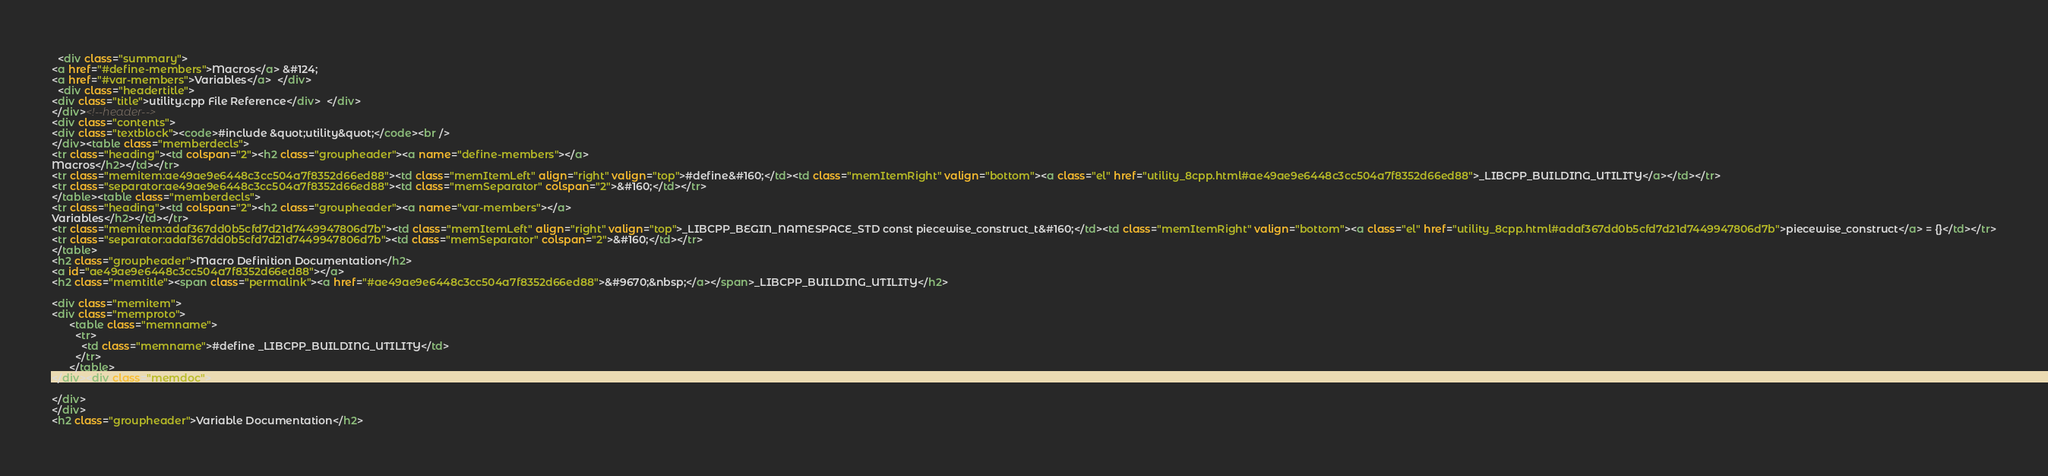<code> <loc_0><loc_0><loc_500><loc_500><_HTML_>  <div class="summary">
<a href="#define-members">Macros</a> &#124;
<a href="#var-members">Variables</a>  </div>
  <div class="headertitle">
<div class="title">utility.cpp File Reference</div>  </div>
</div><!--header-->
<div class="contents">
<div class="textblock"><code>#include &quot;utility&quot;</code><br />
</div><table class="memberdecls">
<tr class="heading"><td colspan="2"><h2 class="groupheader"><a name="define-members"></a>
Macros</h2></td></tr>
<tr class="memitem:ae49ae9e6448c3cc504a7f8352d66ed88"><td class="memItemLeft" align="right" valign="top">#define&#160;</td><td class="memItemRight" valign="bottom"><a class="el" href="utility_8cpp.html#ae49ae9e6448c3cc504a7f8352d66ed88">_LIBCPP_BUILDING_UTILITY</a></td></tr>
<tr class="separator:ae49ae9e6448c3cc504a7f8352d66ed88"><td class="memSeparator" colspan="2">&#160;</td></tr>
</table><table class="memberdecls">
<tr class="heading"><td colspan="2"><h2 class="groupheader"><a name="var-members"></a>
Variables</h2></td></tr>
<tr class="memitem:adaf367dd0b5cfd7d21d7449947806d7b"><td class="memItemLeft" align="right" valign="top">_LIBCPP_BEGIN_NAMESPACE_STD const piecewise_construct_t&#160;</td><td class="memItemRight" valign="bottom"><a class="el" href="utility_8cpp.html#adaf367dd0b5cfd7d21d7449947806d7b">piecewise_construct</a> = {}</td></tr>
<tr class="separator:adaf367dd0b5cfd7d21d7449947806d7b"><td class="memSeparator" colspan="2">&#160;</td></tr>
</table>
<h2 class="groupheader">Macro Definition Documentation</h2>
<a id="ae49ae9e6448c3cc504a7f8352d66ed88"></a>
<h2 class="memtitle"><span class="permalink"><a href="#ae49ae9e6448c3cc504a7f8352d66ed88">&#9670;&nbsp;</a></span>_LIBCPP_BUILDING_UTILITY</h2>

<div class="memitem">
<div class="memproto">
      <table class="memname">
        <tr>
          <td class="memname">#define _LIBCPP_BUILDING_UTILITY</td>
        </tr>
      </table>
</div><div class="memdoc">

</div>
</div>
<h2 class="groupheader">Variable Documentation</h2></code> 